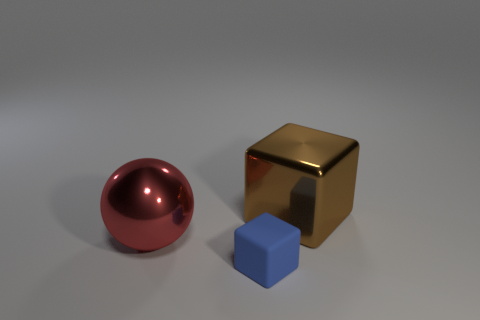Are there any other things that have the same material as the blue block?
Offer a very short reply. No. There is a block that is on the left side of the brown cube; how big is it?
Provide a short and direct response. Small. There is a large object in front of the large metallic object to the right of the rubber block; what is it made of?
Your response must be concise. Metal. How many brown metal cubes are on the right side of the large object in front of the thing that is behind the large ball?
Give a very brief answer. 1. Do the large thing that is to the right of the rubber object and the big thing left of the blue object have the same material?
Provide a short and direct response. Yes. How many other blue rubber objects have the same shape as the tiny object?
Offer a terse response. 0. Is the number of tiny rubber cubes that are in front of the big brown metal object greater than the number of large red rubber blocks?
Provide a short and direct response. Yes. What shape is the thing that is on the right side of the thing that is in front of the thing that is to the left of the small thing?
Keep it short and to the point. Cube. There is a thing that is to the right of the tiny matte object; is it the same shape as the object that is in front of the ball?
Make the answer very short. Yes. Is there anything else that has the same size as the blue thing?
Give a very brief answer. No. 